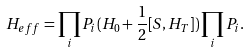Convert formula to latex. <formula><loc_0><loc_0><loc_500><loc_500>H _ { e f f } = \prod _ { i } P _ { i } ( H _ { 0 } + \frac { 1 } { 2 } [ S , H _ { T } ] ) \prod _ { i } P _ { i } .</formula> 